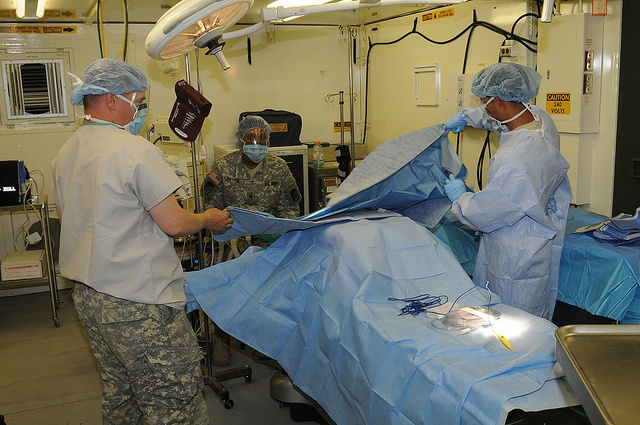Describe the objects in this image and their specific colors. I can see people in tan, darkgray, gray, and black tones, people in tan, darkgray, and gray tones, bed in tan, teal, blue, and gray tones, people in tan, black, darkgreen, and gray tones, and bottle in tan, olive, gray, and black tones in this image. 